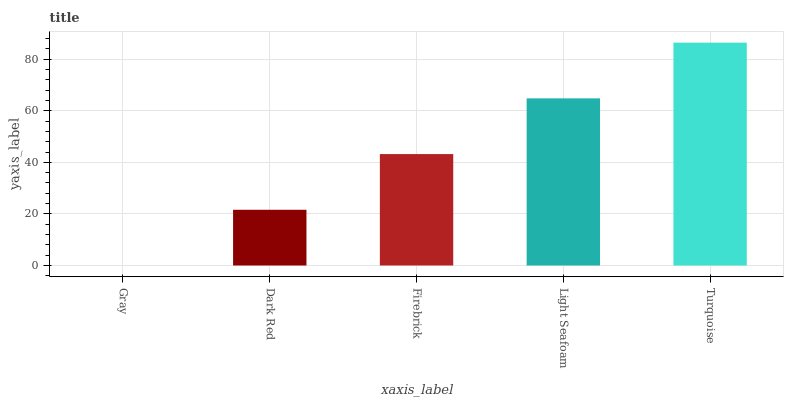Is Gray the minimum?
Answer yes or no. Yes. Is Turquoise the maximum?
Answer yes or no. Yes. Is Dark Red the minimum?
Answer yes or no. No. Is Dark Red the maximum?
Answer yes or no. No. Is Dark Red greater than Gray?
Answer yes or no. Yes. Is Gray less than Dark Red?
Answer yes or no. Yes. Is Gray greater than Dark Red?
Answer yes or no. No. Is Dark Red less than Gray?
Answer yes or no. No. Is Firebrick the high median?
Answer yes or no. Yes. Is Firebrick the low median?
Answer yes or no. Yes. Is Light Seafoam the high median?
Answer yes or no. No. Is Gray the low median?
Answer yes or no. No. 